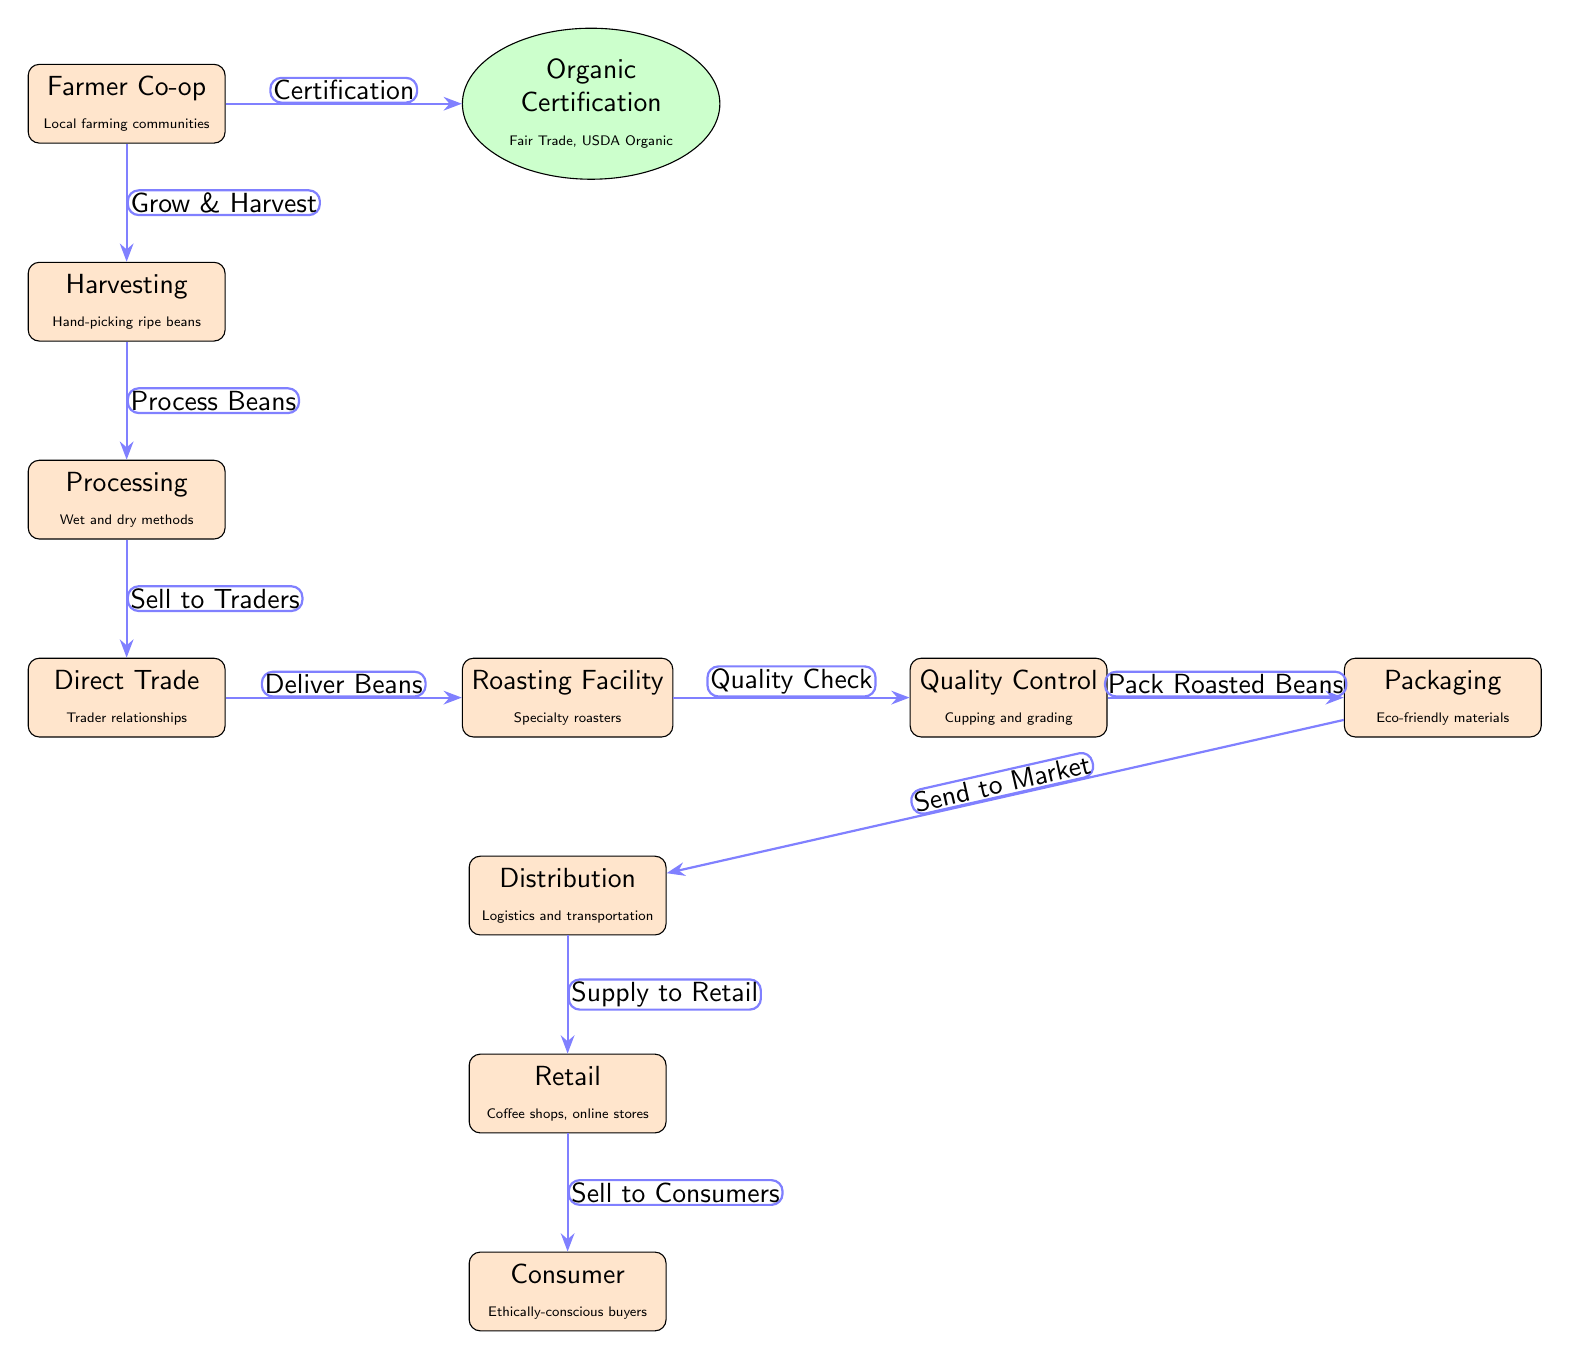What is the first step in the food chain? The first step in the food chain is indicated by the node labeled "Farmer Co-op," which represents the initial source of the coffee beans.
Answer: Farmer Co-op How many processes are there in the food chain? Counting the nodes classified as processes, we find a total of six process nodes, which include harvesting, processing, direct trade, roasting facility, distribution, and retail.
Answer: 6 What certification is required for ethical coffee production? The certification node indicates "Organic Certification," which includes Fair Trade and USDA Organic as specific standards for ethical practices.
Answer: Organic Certification Which node comes after "Processing"? The flow of the diagram shows that the step following "Processing" is "Direct Trade," signifying the sale of processed beans to traders.
Answer: Direct Trade What is the final destination of the coffee beans? The last node in the chain demonstrates that the final destination, where the product reaches the end consumer, is labeled "Consumer."
Answer: Consumer What happens after "Roasting Facility"? The next step in the food chain after "Roasting Facility" is "Quality Control," where roasted beans undergo grading and cupping to ensure quality.
Answer: Quality Control What is the role of the "Farmer Co-op"? The "Farmer Co-op" operates as the initial source of coffee beans, involving local farming communities in the cultivation and harvesting of the beans.
Answer: Local farming communities Which process involves hand-picking ripe beans? The process noted as "Harvesting" specifically mentions hand-picking as the method used for collecting ripe coffee beans.
Answer: Harvesting How are roasted beans packaged? The node labeled "Packaging" specifies that roasted beans are packed using eco-friendly materials, emphasizing sustainable practices in the distribution process.
Answer: Eco-friendly materials 